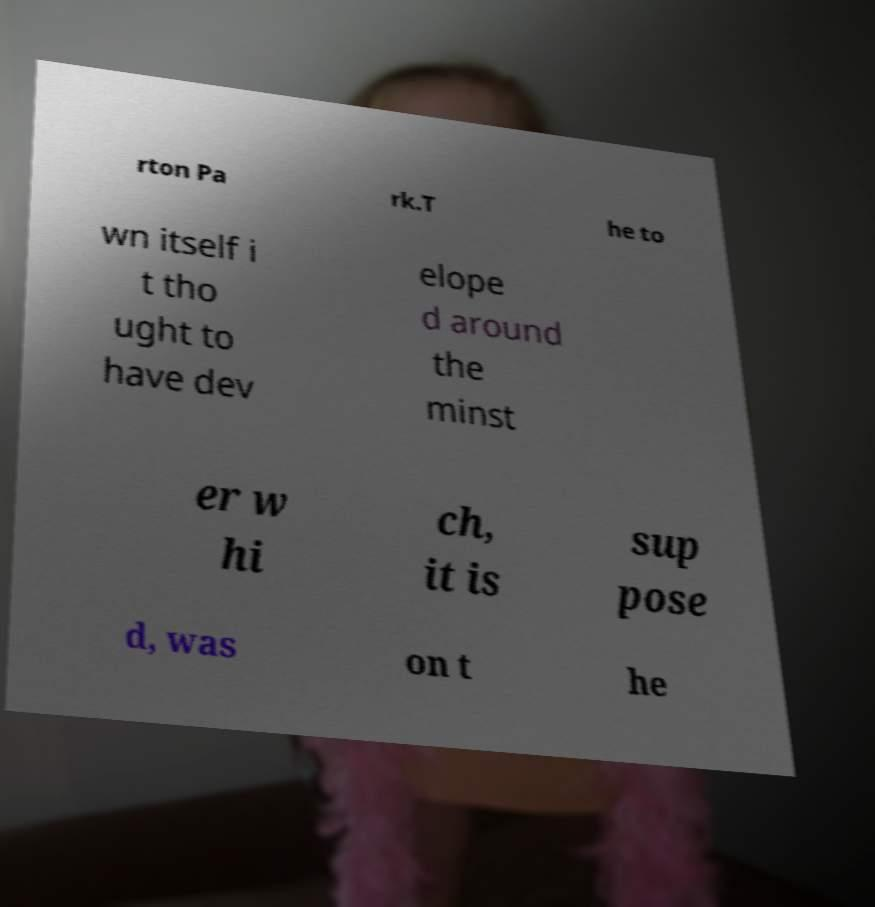I need the written content from this picture converted into text. Can you do that? rton Pa rk.T he to wn itself i t tho ught to have dev elope d around the minst er w hi ch, it is sup pose d, was on t he 